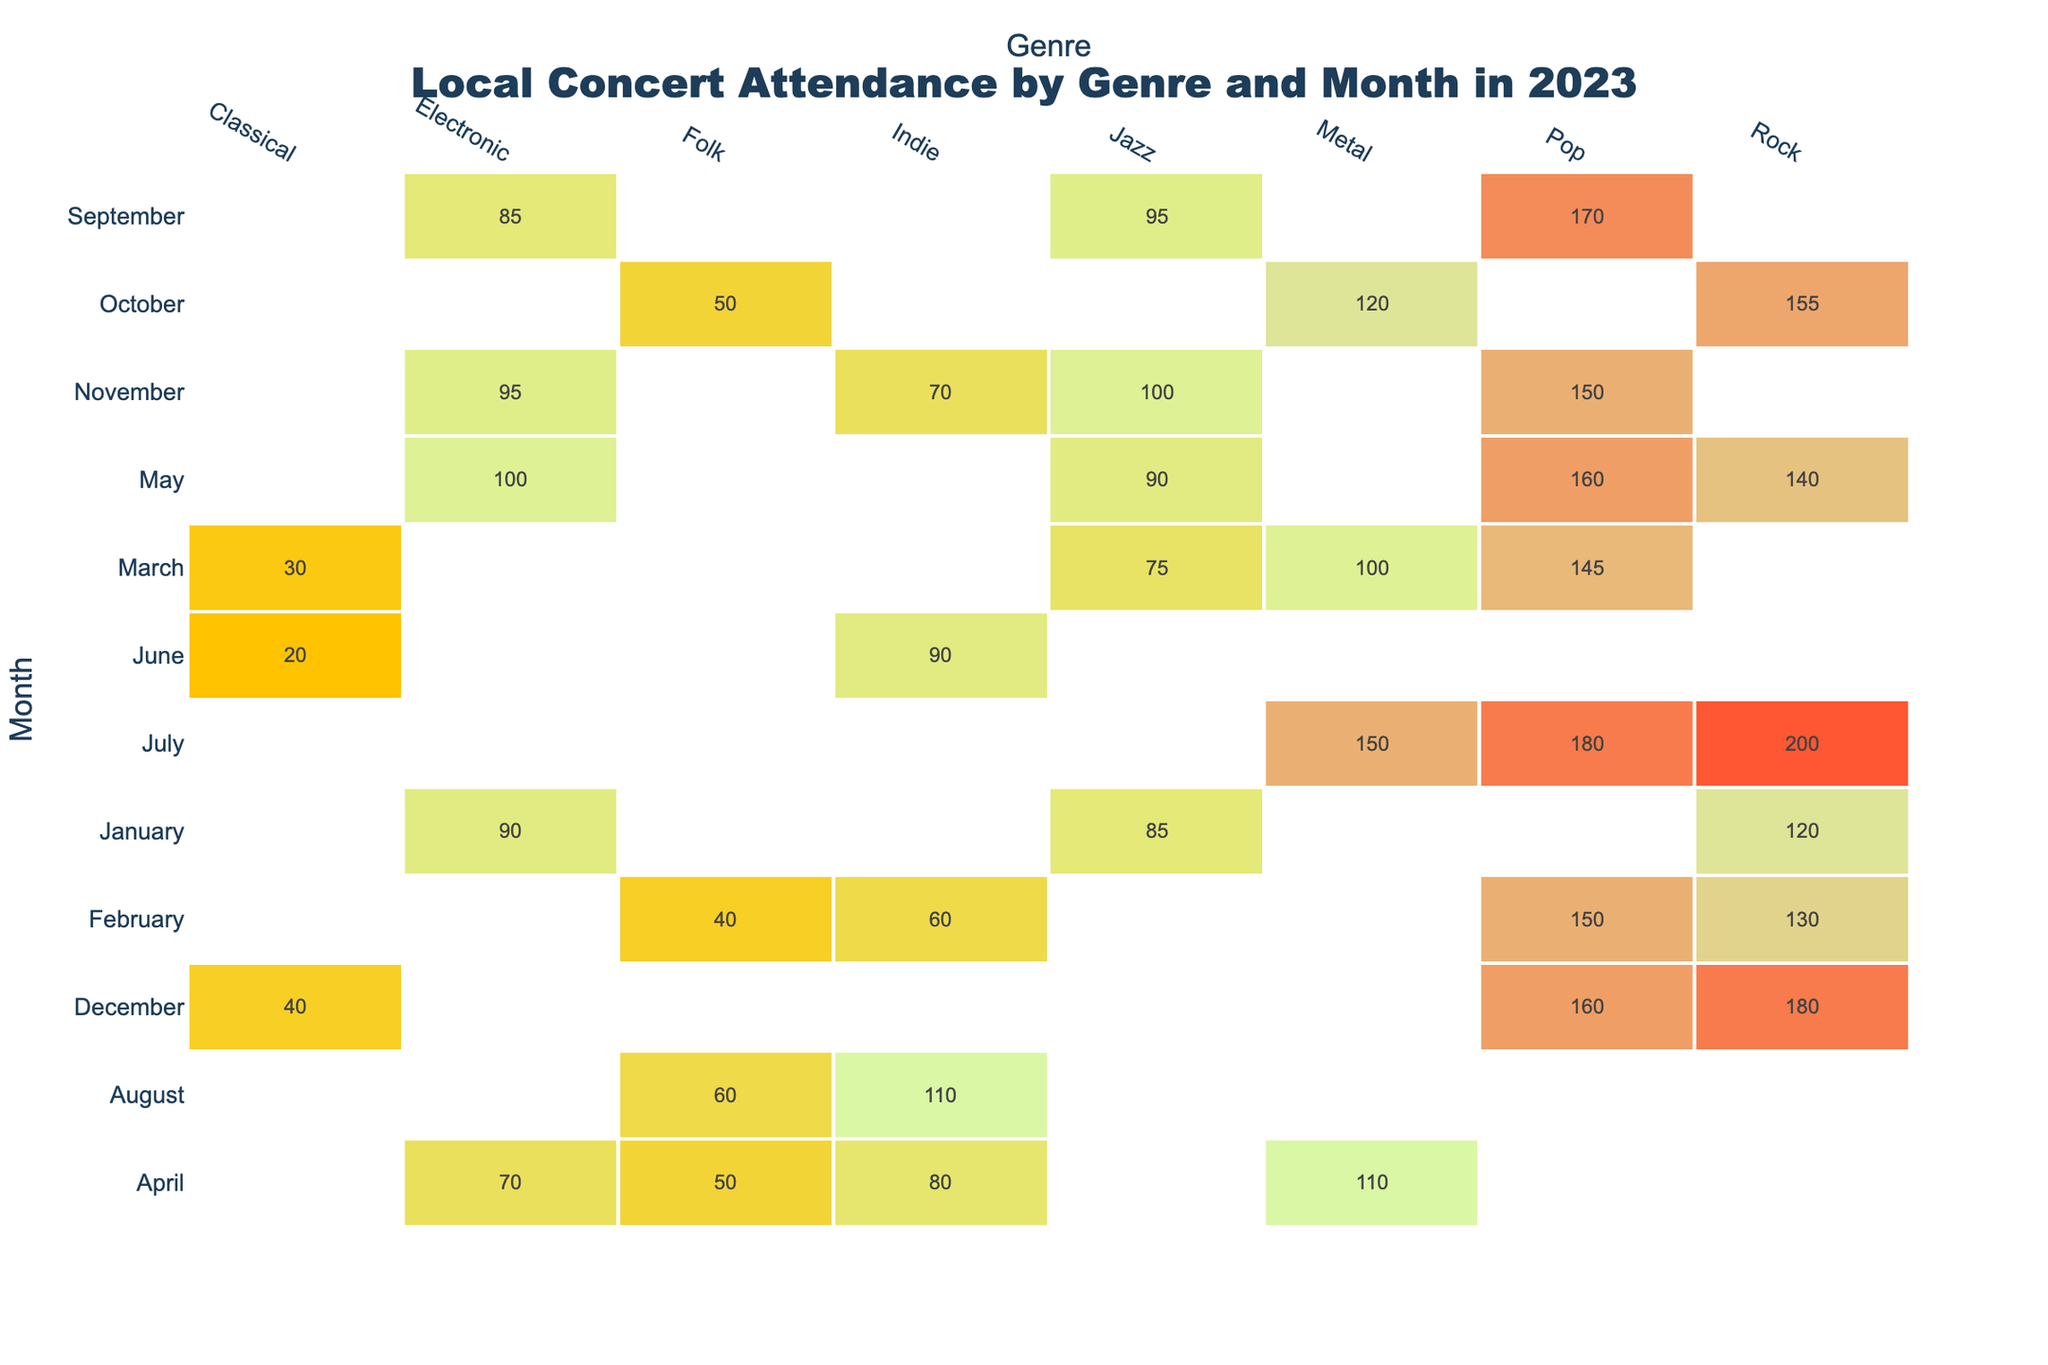What's the highest attendance recorded for Pop concerts? By examining the table, the highest attendance for Pop is 180 in July.
Answer: 180 What was the total attendance for Rock concerts across all months? Adding up the attendances for Rock in each month: 120 (Jan) + 130 (Feb) + 140 (May) + 200 (Jul) + 155 (Oct) + 180 (Dec) = 1025.
Answer: 1025 Was there any month where Jazz concerts had zero attendance? I can check the table for any month where the attendance for Jazz is blank. Jazz shows attendance in every month listed.
Answer: No What month had the least attendance for Classical concerts? Looking at the Classical genre, the only attendance figures are for March (30) and December (40). The least attendance was in March.
Answer: March Which genre had the most total attendance in the month of July? The total attendances for July are Rock (200), Pop (180), and Metal (150). Rock has the highest attendance out of these.
Answer: Rock What is the average attendance for Electronic concerts over the whole year? The total attendance for Electronic is calculated as follows: 90 (Jan) + 70 (Apr) + 100 (May) + 85 (Sep) + 95 (Nov) = 440. There are 5 months of attendance, so the average is 440 / 5 = 88.
Answer: 88 Did Indie concerts have higher attendance than Folk concerts in any month? I will compare the monthly attendances for Indie and Folk: Jan (0 vs 0), Feb (60 vs 40), Apr (80 vs 50), May (0 vs 0), Jun (90 vs 60), Jul (0 vs 0), Aug (110 vs 60), Sep (0 vs 0), Oct (0 vs 0), Nov (70 vs 0), Dec (0 vs 0). Indie had higher attendance in February, April, June, and August.
Answer: Yes What is the percentage increase in attendance for Pop from January to May? The attendance in January was 120, and in May, it was 160. The difference is 40 (160 - 120). The increase is (40 / 120) * 100 = 33.33%.
Answer: 33.33% Count the number of months where Metal concerts had attendance greater than 100. Checking the Metal attendance values: 100 (Mar), 110 (Apr), 150 (Jul), and 120 (Oct), I find there are 4 months where Metal had attendance greater than 100.
Answer: 4 Which genre had the lowest total attendance for the year? Total attendances by genre are: Rock = 1025, Pop = 1000, Jazz = 800, Electronic = 440, Indie = 350, Folk = 200, Metal = 480, and Classical = 70. The lowest attendance is for Classical.
Answer: Classical 